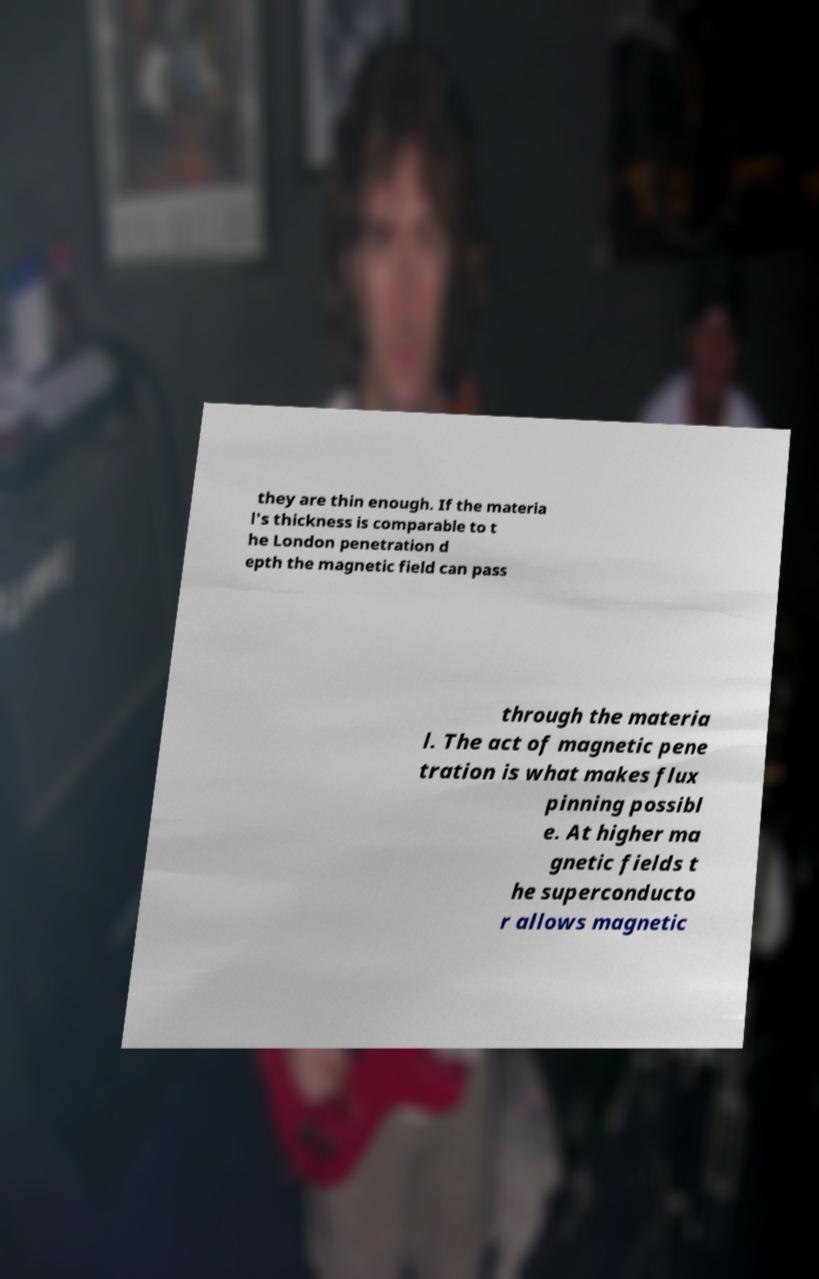Can you read and provide the text displayed in the image?This photo seems to have some interesting text. Can you extract and type it out for me? they are thin enough. If the materia l's thickness is comparable to t he London penetration d epth the magnetic field can pass through the materia l. The act of magnetic pene tration is what makes flux pinning possibl e. At higher ma gnetic fields t he superconducto r allows magnetic 